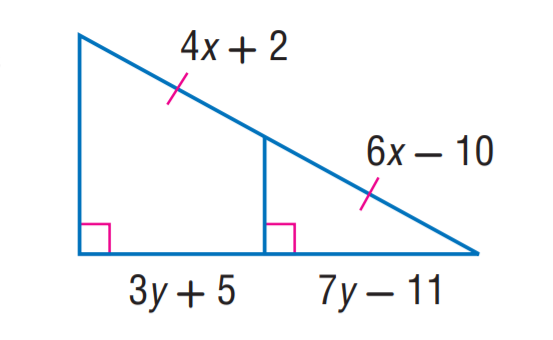Answer the mathemtical geometry problem and directly provide the correct option letter.
Question: Find x.
Choices: A: 3 B: 4 C: 5 D: 6 D 